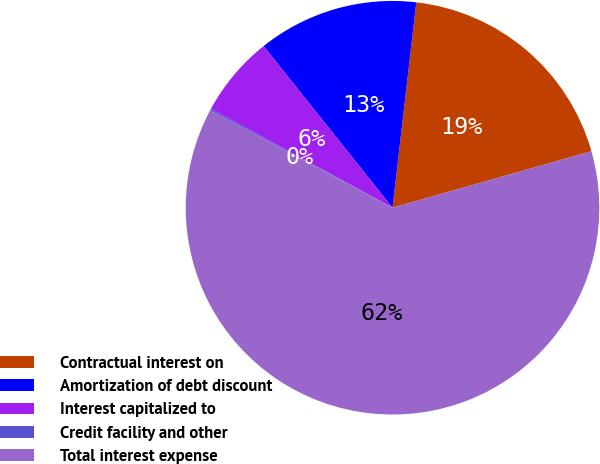<chart> <loc_0><loc_0><loc_500><loc_500><pie_chart><fcel>Contractual interest on<fcel>Amortization of debt discount<fcel>Interest capitalized to<fcel>Credit facility and other<fcel>Total interest expense<nl><fcel>18.76%<fcel>12.55%<fcel>6.34%<fcel>0.13%<fcel>62.22%<nl></chart> 